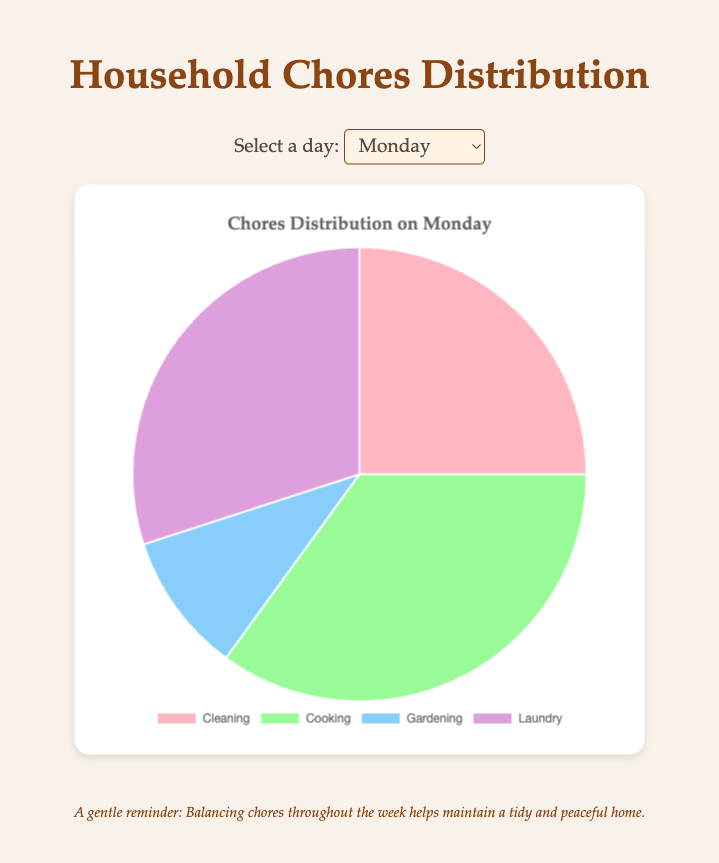Which chore takes up the most time on Monday? Looking at the pie chart for Monday, the slice for Cooking is the largest, indicating it takes up the most time with 35%.
Answer: Cooking How much more time is spent on cleaning on Friday compared to Sunday? Observing the pie chart, cleaning on Friday is 30% while on Sunday it is 20%. The difference is 30% - 20% = 10%.
Answer: 10% On which day is the time spent on gardening the highest? By examining the pie charts for each day, the slice for Gardening on Wednesday is the largest at 15%.
Answer: Wednesday Compare the time spent on laundry on Monday and Wednesday. According to the pie chart, Monday has 30% for laundry, while Wednesday has 35%. Since 35% is greater than 30%, more time is spent on Wednesday.
Answer: Wednesday What is the total combined time spent on Cleaning and Cooking on Friday? Adding the percentages from the pie chart, Cleaning is 30% and Cooking is 40%, so 30% + 40% = 70%.
Answer: 70% Which chore is represented by the purple slice on the pie chart? From the pie chart legend, the purple slice stands for Laundry.
Answer: Laundry Which day has the least time spent on Cooking, and what percentage is it? By comparing the pie charts, Monday and Wednesday have the least time spent on Cooking, both at 30%.
Answer: Wednesday and 30% What is the average time spent on gardening over all four days? To find the average: (10% + 15% + 10% + 10%) / 4 = 45% / 4 = 11.25%.
Answer: 11.25% How does the time spent on cleaning on Monday compare to the time spent on gardening on Wednesday? Cleaning takes 25% on Monday, while Gardening takes 15% on Wednesday. Cleaning on Monday is more by 10%.
Answer: Cleaning on Monday is more by 10% What is the difference in time spent on cooking between Friday and Sunday? Cooking takes 40% on Friday and 50% on Sunday. The difference is 50% - 40% = 10%.
Answer: 10% 